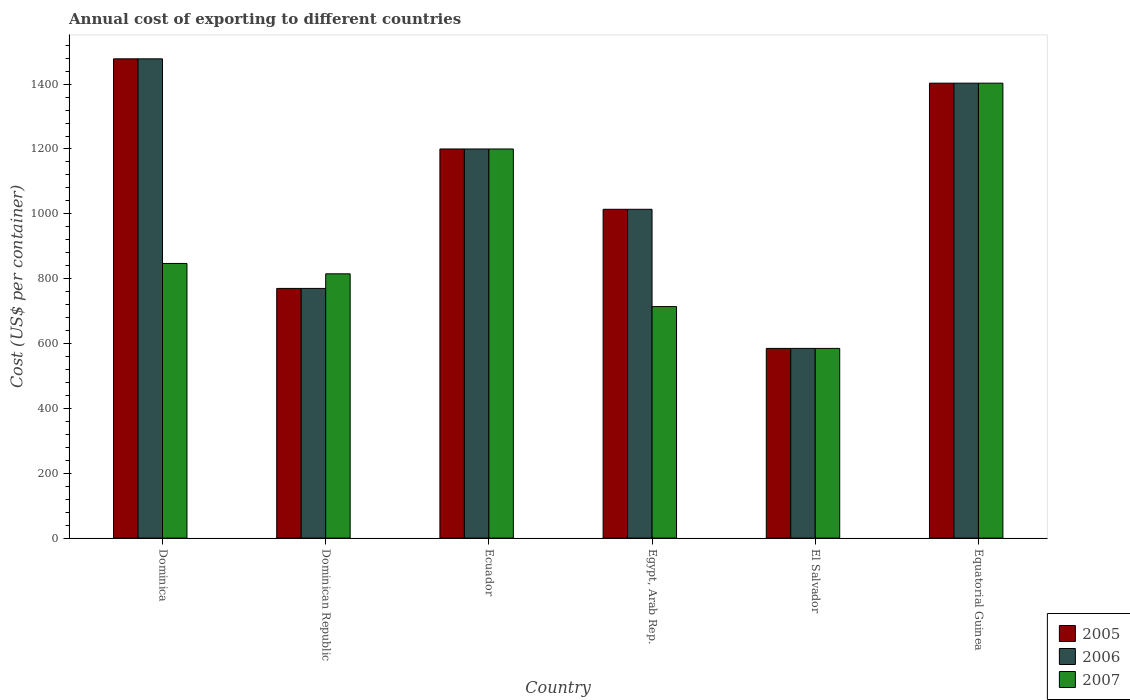How many different coloured bars are there?
Your answer should be very brief. 3. Are the number of bars per tick equal to the number of legend labels?
Your answer should be compact. Yes. Are the number of bars on each tick of the X-axis equal?
Keep it short and to the point. Yes. How many bars are there on the 1st tick from the right?
Your answer should be very brief. 3. What is the label of the 4th group of bars from the left?
Your answer should be compact. Egypt, Arab Rep. In how many cases, is the number of bars for a given country not equal to the number of legend labels?
Your answer should be very brief. 0. What is the total annual cost of exporting in 2006 in Dominican Republic?
Provide a succinct answer. 770. Across all countries, what is the maximum total annual cost of exporting in 2005?
Provide a succinct answer. 1478. Across all countries, what is the minimum total annual cost of exporting in 2007?
Offer a very short reply. 585. In which country was the total annual cost of exporting in 2005 maximum?
Provide a short and direct response. Dominica. In which country was the total annual cost of exporting in 2005 minimum?
Ensure brevity in your answer.  El Salvador. What is the total total annual cost of exporting in 2005 in the graph?
Give a very brief answer. 6450. What is the difference between the total annual cost of exporting in 2007 in Dominican Republic and that in El Salvador?
Your answer should be very brief. 230. What is the difference between the total annual cost of exporting in 2006 in Equatorial Guinea and the total annual cost of exporting in 2007 in El Salvador?
Provide a succinct answer. 818. What is the average total annual cost of exporting in 2005 per country?
Offer a terse response. 1075. In how many countries, is the total annual cost of exporting in 2005 greater than 760 US$?
Your answer should be compact. 5. What is the ratio of the total annual cost of exporting in 2006 in Egypt, Arab Rep. to that in Equatorial Guinea?
Make the answer very short. 0.72. Is the total annual cost of exporting in 2007 in Dominica less than that in Dominican Republic?
Offer a terse response. No. What is the difference between the highest and the second highest total annual cost of exporting in 2006?
Keep it short and to the point. -203. What is the difference between the highest and the lowest total annual cost of exporting in 2006?
Provide a succinct answer. 893. In how many countries, is the total annual cost of exporting in 2006 greater than the average total annual cost of exporting in 2006 taken over all countries?
Your answer should be compact. 3. Is the sum of the total annual cost of exporting in 2006 in Ecuador and El Salvador greater than the maximum total annual cost of exporting in 2005 across all countries?
Keep it short and to the point. Yes. What does the 1st bar from the right in Egypt, Arab Rep. represents?
Your answer should be compact. 2007. Are all the bars in the graph horizontal?
Offer a very short reply. No. How many legend labels are there?
Give a very brief answer. 3. What is the title of the graph?
Your answer should be compact. Annual cost of exporting to different countries. Does "1998" appear as one of the legend labels in the graph?
Provide a succinct answer. No. What is the label or title of the Y-axis?
Give a very brief answer. Cost (US$ per container). What is the Cost (US$ per container) of 2005 in Dominica?
Make the answer very short. 1478. What is the Cost (US$ per container) of 2006 in Dominica?
Offer a terse response. 1478. What is the Cost (US$ per container) of 2007 in Dominica?
Your answer should be compact. 847. What is the Cost (US$ per container) in 2005 in Dominican Republic?
Your answer should be very brief. 770. What is the Cost (US$ per container) in 2006 in Dominican Republic?
Your response must be concise. 770. What is the Cost (US$ per container) in 2007 in Dominican Republic?
Provide a succinct answer. 815. What is the Cost (US$ per container) in 2005 in Ecuador?
Give a very brief answer. 1200. What is the Cost (US$ per container) of 2006 in Ecuador?
Offer a very short reply. 1200. What is the Cost (US$ per container) in 2007 in Ecuador?
Your response must be concise. 1200. What is the Cost (US$ per container) in 2005 in Egypt, Arab Rep.?
Make the answer very short. 1014. What is the Cost (US$ per container) in 2006 in Egypt, Arab Rep.?
Provide a succinct answer. 1014. What is the Cost (US$ per container) of 2007 in Egypt, Arab Rep.?
Offer a terse response. 714. What is the Cost (US$ per container) in 2005 in El Salvador?
Your response must be concise. 585. What is the Cost (US$ per container) of 2006 in El Salvador?
Ensure brevity in your answer.  585. What is the Cost (US$ per container) of 2007 in El Salvador?
Your answer should be compact. 585. What is the Cost (US$ per container) in 2005 in Equatorial Guinea?
Make the answer very short. 1403. What is the Cost (US$ per container) of 2006 in Equatorial Guinea?
Offer a very short reply. 1403. What is the Cost (US$ per container) in 2007 in Equatorial Guinea?
Provide a short and direct response. 1403. Across all countries, what is the maximum Cost (US$ per container) of 2005?
Make the answer very short. 1478. Across all countries, what is the maximum Cost (US$ per container) in 2006?
Your answer should be very brief. 1478. Across all countries, what is the maximum Cost (US$ per container) in 2007?
Your response must be concise. 1403. Across all countries, what is the minimum Cost (US$ per container) in 2005?
Keep it short and to the point. 585. Across all countries, what is the minimum Cost (US$ per container) in 2006?
Offer a very short reply. 585. Across all countries, what is the minimum Cost (US$ per container) in 2007?
Your answer should be very brief. 585. What is the total Cost (US$ per container) of 2005 in the graph?
Make the answer very short. 6450. What is the total Cost (US$ per container) of 2006 in the graph?
Keep it short and to the point. 6450. What is the total Cost (US$ per container) in 2007 in the graph?
Offer a terse response. 5564. What is the difference between the Cost (US$ per container) of 2005 in Dominica and that in Dominican Republic?
Your response must be concise. 708. What is the difference between the Cost (US$ per container) of 2006 in Dominica and that in Dominican Republic?
Provide a succinct answer. 708. What is the difference between the Cost (US$ per container) of 2007 in Dominica and that in Dominican Republic?
Your response must be concise. 32. What is the difference between the Cost (US$ per container) of 2005 in Dominica and that in Ecuador?
Give a very brief answer. 278. What is the difference between the Cost (US$ per container) in 2006 in Dominica and that in Ecuador?
Offer a terse response. 278. What is the difference between the Cost (US$ per container) in 2007 in Dominica and that in Ecuador?
Provide a short and direct response. -353. What is the difference between the Cost (US$ per container) in 2005 in Dominica and that in Egypt, Arab Rep.?
Offer a terse response. 464. What is the difference between the Cost (US$ per container) of 2006 in Dominica and that in Egypt, Arab Rep.?
Give a very brief answer. 464. What is the difference between the Cost (US$ per container) in 2007 in Dominica and that in Egypt, Arab Rep.?
Provide a succinct answer. 133. What is the difference between the Cost (US$ per container) of 2005 in Dominica and that in El Salvador?
Offer a very short reply. 893. What is the difference between the Cost (US$ per container) of 2006 in Dominica and that in El Salvador?
Keep it short and to the point. 893. What is the difference between the Cost (US$ per container) of 2007 in Dominica and that in El Salvador?
Your answer should be very brief. 262. What is the difference between the Cost (US$ per container) of 2005 in Dominica and that in Equatorial Guinea?
Provide a short and direct response. 75. What is the difference between the Cost (US$ per container) in 2006 in Dominica and that in Equatorial Guinea?
Offer a very short reply. 75. What is the difference between the Cost (US$ per container) of 2007 in Dominica and that in Equatorial Guinea?
Ensure brevity in your answer.  -556. What is the difference between the Cost (US$ per container) of 2005 in Dominican Republic and that in Ecuador?
Provide a short and direct response. -430. What is the difference between the Cost (US$ per container) in 2006 in Dominican Republic and that in Ecuador?
Keep it short and to the point. -430. What is the difference between the Cost (US$ per container) in 2007 in Dominican Republic and that in Ecuador?
Ensure brevity in your answer.  -385. What is the difference between the Cost (US$ per container) in 2005 in Dominican Republic and that in Egypt, Arab Rep.?
Offer a terse response. -244. What is the difference between the Cost (US$ per container) in 2006 in Dominican Republic and that in Egypt, Arab Rep.?
Your answer should be compact. -244. What is the difference between the Cost (US$ per container) of 2007 in Dominican Republic and that in Egypt, Arab Rep.?
Provide a succinct answer. 101. What is the difference between the Cost (US$ per container) of 2005 in Dominican Republic and that in El Salvador?
Your answer should be very brief. 185. What is the difference between the Cost (US$ per container) of 2006 in Dominican Republic and that in El Salvador?
Your answer should be compact. 185. What is the difference between the Cost (US$ per container) of 2007 in Dominican Republic and that in El Salvador?
Offer a terse response. 230. What is the difference between the Cost (US$ per container) of 2005 in Dominican Republic and that in Equatorial Guinea?
Your answer should be very brief. -633. What is the difference between the Cost (US$ per container) of 2006 in Dominican Republic and that in Equatorial Guinea?
Your response must be concise. -633. What is the difference between the Cost (US$ per container) of 2007 in Dominican Republic and that in Equatorial Guinea?
Make the answer very short. -588. What is the difference between the Cost (US$ per container) in 2005 in Ecuador and that in Egypt, Arab Rep.?
Make the answer very short. 186. What is the difference between the Cost (US$ per container) in 2006 in Ecuador and that in Egypt, Arab Rep.?
Offer a very short reply. 186. What is the difference between the Cost (US$ per container) in 2007 in Ecuador and that in Egypt, Arab Rep.?
Your answer should be very brief. 486. What is the difference between the Cost (US$ per container) of 2005 in Ecuador and that in El Salvador?
Give a very brief answer. 615. What is the difference between the Cost (US$ per container) of 2006 in Ecuador and that in El Salvador?
Provide a short and direct response. 615. What is the difference between the Cost (US$ per container) of 2007 in Ecuador and that in El Salvador?
Your answer should be compact. 615. What is the difference between the Cost (US$ per container) in 2005 in Ecuador and that in Equatorial Guinea?
Your answer should be very brief. -203. What is the difference between the Cost (US$ per container) of 2006 in Ecuador and that in Equatorial Guinea?
Give a very brief answer. -203. What is the difference between the Cost (US$ per container) in 2007 in Ecuador and that in Equatorial Guinea?
Give a very brief answer. -203. What is the difference between the Cost (US$ per container) of 2005 in Egypt, Arab Rep. and that in El Salvador?
Provide a succinct answer. 429. What is the difference between the Cost (US$ per container) of 2006 in Egypt, Arab Rep. and that in El Salvador?
Your answer should be very brief. 429. What is the difference between the Cost (US$ per container) of 2007 in Egypt, Arab Rep. and that in El Salvador?
Offer a very short reply. 129. What is the difference between the Cost (US$ per container) of 2005 in Egypt, Arab Rep. and that in Equatorial Guinea?
Your answer should be very brief. -389. What is the difference between the Cost (US$ per container) in 2006 in Egypt, Arab Rep. and that in Equatorial Guinea?
Ensure brevity in your answer.  -389. What is the difference between the Cost (US$ per container) of 2007 in Egypt, Arab Rep. and that in Equatorial Guinea?
Offer a terse response. -689. What is the difference between the Cost (US$ per container) of 2005 in El Salvador and that in Equatorial Guinea?
Provide a succinct answer. -818. What is the difference between the Cost (US$ per container) of 2006 in El Salvador and that in Equatorial Guinea?
Give a very brief answer. -818. What is the difference between the Cost (US$ per container) of 2007 in El Salvador and that in Equatorial Guinea?
Your response must be concise. -818. What is the difference between the Cost (US$ per container) in 2005 in Dominica and the Cost (US$ per container) in 2006 in Dominican Republic?
Make the answer very short. 708. What is the difference between the Cost (US$ per container) in 2005 in Dominica and the Cost (US$ per container) in 2007 in Dominican Republic?
Offer a terse response. 663. What is the difference between the Cost (US$ per container) in 2006 in Dominica and the Cost (US$ per container) in 2007 in Dominican Republic?
Provide a succinct answer. 663. What is the difference between the Cost (US$ per container) in 2005 in Dominica and the Cost (US$ per container) in 2006 in Ecuador?
Keep it short and to the point. 278. What is the difference between the Cost (US$ per container) in 2005 in Dominica and the Cost (US$ per container) in 2007 in Ecuador?
Your answer should be very brief. 278. What is the difference between the Cost (US$ per container) in 2006 in Dominica and the Cost (US$ per container) in 2007 in Ecuador?
Your answer should be compact. 278. What is the difference between the Cost (US$ per container) of 2005 in Dominica and the Cost (US$ per container) of 2006 in Egypt, Arab Rep.?
Keep it short and to the point. 464. What is the difference between the Cost (US$ per container) of 2005 in Dominica and the Cost (US$ per container) of 2007 in Egypt, Arab Rep.?
Offer a very short reply. 764. What is the difference between the Cost (US$ per container) of 2006 in Dominica and the Cost (US$ per container) of 2007 in Egypt, Arab Rep.?
Make the answer very short. 764. What is the difference between the Cost (US$ per container) of 2005 in Dominica and the Cost (US$ per container) of 2006 in El Salvador?
Offer a terse response. 893. What is the difference between the Cost (US$ per container) in 2005 in Dominica and the Cost (US$ per container) in 2007 in El Salvador?
Keep it short and to the point. 893. What is the difference between the Cost (US$ per container) of 2006 in Dominica and the Cost (US$ per container) of 2007 in El Salvador?
Give a very brief answer. 893. What is the difference between the Cost (US$ per container) in 2005 in Dominica and the Cost (US$ per container) in 2006 in Equatorial Guinea?
Offer a terse response. 75. What is the difference between the Cost (US$ per container) of 2005 in Dominica and the Cost (US$ per container) of 2007 in Equatorial Guinea?
Offer a terse response. 75. What is the difference between the Cost (US$ per container) in 2005 in Dominican Republic and the Cost (US$ per container) in 2006 in Ecuador?
Provide a short and direct response. -430. What is the difference between the Cost (US$ per container) in 2005 in Dominican Republic and the Cost (US$ per container) in 2007 in Ecuador?
Keep it short and to the point. -430. What is the difference between the Cost (US$ per container) in 2006 in Dominican Republic and the Cost (US$ per container) in 2007 in Ecuador?
Your answer should be very brief. -430. What is the difference between the Cost (US$ per container) in 2005 in Dominican Republic and the Cost (US$ per container) in 2006 in Egypt, Arab Rep.?
Offer a very short reply. -244. What is the difference between the Cost (US$ per container) in 2005 in Dominican Republic and the Cost (US$ per container) in 2006 in El Salvador?
Your answer should be very brief. 185. What is the difference between the Cost (US$ per container) in 2005 in Dominican Republic and the Cost (US$ per container) in 2007 in El Salvador?
Your response must be concise. 185. What is the difference between the Cost (US$ per container) of 2006 in Dominican Republic and the Cost (US$ per container) of 2007 in El Salvador?
Offer a very short reply. 185. What is the difference between the Cost (US$ per container) in 2005 in Dominican Republic and the Cost (US$ per container) in 2006 in Equatorial Guinea?
Your answer should be very brief. -633. What is the difference between the Cost (US$ per container) in 2005 in Dominican Republic and the Cost (US$ per container) in 2007 in Equatorial Guinea?
Give a very brief answer. -633. What is the difference between the Cost (US$ per container) in 2006 in Dominican Republic and the Cost (US$ per container) in 2007 in Equatorial Guinea?
Keep it short and to the point. -633. What is the difference between the Cost (US$ per container) in 2005 in Ecuador and the Cost (US$ per container) in 2006 in Egypt, Arab Rep.?
Keep it short and to the point. 186. What is the difference between the Cost (US$ per container) of 2005 in Ecuador and the Cost (US$ per container) of 2007 in Egypt, Arab Rep.?
Ensure brevity in your answer.  486. What is the difference between the Cost (US$ per container) in 2006 in Ecuador and the Cost (US$ per container) in 2007 in Egypt, Arab Rep.?
Provide a succinct answer. 486. What is the difference between the Cost (US$ per container) of 2005 in Ecuador and the Cost (US$ per container) of 2006 in El Salvador?
Provide a succinct answer. 615. What is the difference between the Cost (US$ per container) of 2005 in Ecuador and the Cost (US$ per container) of 2007 in El Salvador?
Your answer should be compact. 615. What is the difference between the Cost (US$ per container) in 2006 in Ecuador and the Cost (US$ per container) in 2007 in El Salvador?
Your answer should be very brief. 615. What is the difference between the Cost (US$ per container) of 2005 in Ecuador and the Cost (US$ per container) of 2006 in Equatorial Guinea?
Make the answer very short. -203. What is the difference between the Cost (US$ per container) of 2005 in Ecuador and the Cost (US$ per container) of 2007 in Equatorial Guinea?
Give a very brief answer. -203. What is the difference between the Cost (US$ per container) of 2006 in Ecuador and the Cost (US$ per container) of 2007 in Equatorial Guinea?
Make the answer very short. -203. What is the difference between the Cost (US$ per container) in 2005 in Egypt, Arab Rep. and the Cost (US$ per container) in 2006 in El Salvador?
Ensure brevity in your answer.  429. What is the difference between the Cost (US$ per container) of 2005 in Egypt, Arab Rep. and the Cost (US$ per container) of 2007 in El Salvador?
Ensure brevity in your answer.  429. What is the difference between the Cost (US$ per container) in 2006 in Egypt, Arab Rep. and the Cost (US$ per container) in 2007 in El Salvador?
Your response must be concise. 429. What is the difference between the Cost (US$ per container) of 2005 in Egypt, Arab Rep. and the Cost (US$ per container) of 2006 in Equatorial Guinea?
Provide a succinct answer. -389. What is the difference between the Cost (US$ per container) of 2005 in Egypt, Arab Rep. and the Cost (US$ per container) of 2007 in Equatorial Guinea?
Provide a short and direct response. -389. What is the difference between the Cost (US$ per container) in 2006 in Egypt, Arab Rep. and the Cost (US$ per container) in 2007 in Equatorial Guinea?
Offer a terse response. -389. What is the difference between the Cost (US$ per container) of 2005 in El Salvador and the Cost (US$ per container) of 2006 in Equatorial Guinea?
Offer a terse response. -818. What is the difference between the Cost (US$ per container) of 2005 in El Salvador and the Cost (US$ per container) of 2007 in Equatorial Guinea?
Your answer should be very brief. -818. What is the difference between the Cost (US$ per container) of 2006 in El Salvador and the Cost (US$ per container) of 2007 in Equatorial Guinea?
Your answer should be compact. -818. What is the average Cost (US$ per container) in 2005 per country?
Provide a short and direct response. 1075. What is the average Cost (US$ per container) in 2006 per country?
Your answer should be very brief. 1075. What is the average Cost (US$ per container) of 2007 per country?
Give a very brief answer. 927.33. What is the difference between the Cost (US$ per container) of 2005 and Cost (US$ per container) of 2007 in Dominica?
Your answer should be compact. 631. What is the difference between the Cost (US$ per container) of 2006 and Cost (US$ per container) of 2007 in Dominica?
Offer a terse response. 631. What is the difference between the Cost (US$ per container) of 2005 and Cost (US$ per container) of 2006 in Dominican Republic?
Give a very brief answer. 0. What is the difference between the Cost (US$ per container) of 2005 and Cost (US$ per container) of 2007 in Dominican Republic?
Your response must be concise. -45. What is the difference between the Cost (US$ per container) in 2006 and Cost (US$ per container) in 2007 in Dominican Republic?
Your response must be concise. -45. What is the difference between the Cost (US$ per container) of 2005 and Cost (US$ per container) of 2006 in Egypt, Arab Rep.?
Your response must be concise. 0. What is the difference between the Cost (US$ per container) of 2005 and Cost (US$ per container) of 2007 in Egypt, Arab Rep.?
Give a very brief answer. 300. What is the difference between the Cost (US$ per container) of 2006 and Cost (US$ per container) of 2007 in Egypt, Arab Rep.?
Your answer should be very brief. 300. What is the difference between the Cost (US$ per container) of 2005 and Cost (US$ per container) of 2006 in El Salvador?
Give a very brief answer. 0. What is the difference between the Cost (US$ per container) of 2005 and Cost (US$ per container) of 2007 in El Salvador?
Provide a succinct answer. 0. What is the difference between the Cost (US$ per container) in 2006 and Cost (US$ per container) in 2007 in El Salvador?
Give a very brief answer. 0. What is the difference between the Cost (US$ per container) of 2005 and Cost (US$ per container) of 2006 in Equatorial Guinea?
Ensure brevity in your answer.  0. What is the difference between the Cost (US$ per container) in 2006 and Cost (US$ per container) in 2007 in Equatorial Guinea?
Provide a succinct answer. 0. What is the ratio of the Cost (US$ per container) in 2005 in Dominica to that in Dominican Republic?
Your answer should be very brief. 1.92. What is the ratio of the Cost (US$ per container) of 2006 in Dominica to that in Dominican Republic?
Offer a very short reply. 1.92. What is the ratio of the Cost (US$ per container) in 2007 in Dominica to that in Dominican Republic?
Provide a short and direct response. 1.04. What is the ratio of the Cost (US$ per container) of 2005 in Dominica to that in Ecuador?
Ensure brevity in your answer.  1.23. What is the ratio of the Cost (US$ per container) in 2006 in Dominica to that in Ecuador?
Provide a succinct answer. 1.23. What is the ratio of the Cost (US$ per container) of 2007 in Dominica to that in Ecuador?
Offer a terse response. 0.71. What is the ratio of the Cost (US$ per container) of 2005 in Dominica to that in Egypt, Arab Rep.?
Ensure brevity in your answer.  1.46. What is the ratio of the Cost (US$ per container) in 2006 in Dominica to that in Egypt, Arab Rep.?
Keep it short and to the point. 1.46. What is the ratio of the Cost (US$ per container) in 2007 in Dominica to that in Egypt, Arab Rep.?
Your answer should be compact. 1.19. What is the ratio of the Cost (US$ per container) of 2005 in Dominica to that in El Salvador?
Your answer should be very brief. 2.53. What is the ratio of the Cost (US$ per container) in 2006 in Dominica to that in El Salvador?
Give a very brief answer. 2.53. What is the ratio of the Cost (US$ per container) of 2007 in Dominica to that in El Salvador?
Offer a very short reply. 1.45. What is the ratio of the Cost (US$ per container) of 2005 in Dominica to that in Equatorial Guinea?
Your response must be concise. 1.05. What is the ratio of the Cost (US$ per container) in 2006 in Dominica to that in Equatorial Guinea?
Ensure brevity in your answer.  1.05. What is the ratio of the Cost (US$ per container) of 2007 in Dominica to that in Equatorial Guinea?
Offer a terse response. 0.6. What is the ratio of the Cost (US$ per container) in 2005 in Dominican Republic to that in Ecuador?
Keep it short and to the point. 0.64. What is the ratio of the Cost (US$ per container) of 2006 in Dominican Republic to that in Ecuador?
Give a very brief answer. 0.64. What is the ratio of the Cost (US$ per container) of 2007 in Dominican Republic to that in Ecuador?
Offer a very short reply. 0.68. What is the ratio of the Cost (US$ per container) in 2005 in Dominican Republic to that in Egypt, Arab Rep.?
Provide a short and direct response. 0.76. What is the ratio of the Cost (US$ per container) in 2006 in Dominican Republic to that in Egypt, Arab Rep.?
Offer a very short reply. 0.76. What is the ratio of the Cost (US$ per container) of 2007 in Dominican Republic to that in Egypt, Arab Rep.?
Ensure brevity in your answer.  1.14. What is the ratio of the Cost (US$ per container) in 2005 in Dominican Republic to that in El Salvador?
Make the answer very short. 1.32. What is the ratio of the Cost (US$ per container) in 2006 in Dominican Republic to that in El Salvador?
Make the answer very short. 1.32. What is the ratio of the Cost (US$ per container) of 2007 in Dominican Republic to that in El Salvador?
Your answer should be compact. 1.39. What is the ratio of the Cost (US$ per container) in 2005 in Dominican Republic to that in Equatorial Guinea?
Offer a very short reply. 0.55. What is the ratio of the Cost (US$ per container) in 2006 in Dominican Republic to that in Equatorial Guinea?
Ensure brevity in your answer.  0.55. What is the ratio of the Cost (US$ per container) in 2007 in Dominican Republic to that in Equatorial Guinea?
Your response must be concise. 0.58. What is the ratio of the Cost (US$ per container) of 2005 in Ecuador to that in Egypt, Arab Rep.?
Your answer should be very brief. 1.18. What is the ratio of the Cost (US$ per container) of 2006 in Ecuador to that in Egypt, Arab Rep.?
Keep it short and to the point. 1.18. What is the ratio of the Cost (US$ per container) of 2007 in Ecuador to that in Egypt, Arab Rep.?
Your response must be concise. 1.68. What is the ratio of the Cost (US$ per container) of 2005 in Ecuador to that in El Salvador?
Provide a short and direct response. 2.05. What is the ratio of the Cost (US$ per container) of 2006 in Ecuador to that in El Salvador?
Offer a terse response. 2.05. What is the ratio of the Cost (US$ per container) in 2007 in Ecuador to that in El Salvador?
Your answer should be compact. 2.05. What is the ratio of the Cost (US$ per container) of 2005 in Ecuador to that in Equatorial Guinea?
Provide a succinct answer. 0.86. What is the ratio of the Cost (US$ per container) in 2006 in Ecuador to that in Equatorial Guinea?
Offer a very short reply. 0.86. What is the ratio of the Cost (US$ per container) of 2007 in Ecuador to that in Equatorial Guinea?
Keep it short and to the point. 0.86. What is the ratio of the Cost (US$ per container) in 2005 in Egypt, Arab Rep. to that in El Salvador?
Your response must be concise. 1.73. What is the ratio of the Cost (US$ per container) of 2006 in Egypt, Arab Rep. to that in El Salvador?
Give a very brief answer. 1.73. What is the ratio of the Cost (US$ per container) in 2007 in Egypt, Arab Rep. to that in El Salvador?
Keep it short and to the point. 1.22. What is the ratio of the Cost (US$ per container) in 2005 in Egypt, Arab Rep. to that in Equatorial Guinea?
Give a very brief answer. 0.72. What is the ratio of the Cost (US$ per container) in 2006 in Egypt, Arab Rep. to that in Equatorial Guinea?
Ensure brevity in your answer.  0.72. What is the ratio of the Cost (US$ per container) in 2007 in Egypt, Arab Rep. to that in Equatorial Guinea?
Offer a very short reply. 0.51. What is the ratio of the Cost (US$ per container) of 2005 in El Salvador to that in Equatorial Guinea?
Your answer should be very brief. 0.42. What is the ratio of the Cost (US$ per container) in 2006 in El Salvador to that in Equatorial Guinea?
Provide a succinct answer. 0.42. What is the ratio of the Cost (US$ per container) in 2007 in El Salvador to that in Equatorial Guinea?
Make the answer very short. 0.42. What is the difference between the highest and the second highest Cost (US$ per container) in 2006?
Make the answer very short. 75. What is the difference between the highest and the second highest Cost (US$ per container) in 2007?
Offer a very short reply. 203. What is the difference between the highest and the lowest Cost (US$ per container) of 2005?
Offer a terse response. 893. What is the difference between the highest and the lowest Cost (US$ per container) in 2006?
Ensure brevity in your answer.  893. What is the difference between the highest and the lowest Cost (US$ per container) in 2007?
Offer a very short reply. 818. 